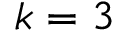Convert formula to latex. <formula><loc_0><loc_0><loc_500><loc_500>k = 3</formula> 